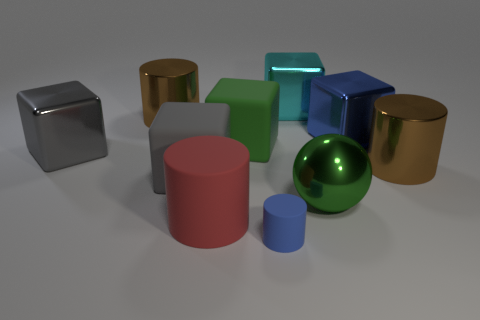What material is the large brown cylinder that is right of the small rubber cylinder to the right of the green thing left of the cyan object made of?
Your answer should be compact. Metal. Are there any other things that have the same size as the green shiny thing?
Offer a terse response. Yes. What number of matte things are big blocks or small blue cylinders?
Offer a very short reply. 3. Are there any green rubber cubes?
Give a very brief answer. Yes. There is a big shiny cylinder behind the large brown cylinder to the right of the large cyan object; what color is it?
Provide a succinct answer. Brown. How many other objects are the same color as the metal sphere?
Offer a terse response. 1. What number of objects are either cylinders or large blue metal blocks that are in front of the cyan metal block?
Make the answer very short. 5. What color is the metal cube that is to the right of the big green metal sphere?
Your answer should be very brief. Blue. What shape is the large cyan object?
Keep it short and to the point. Cube. The gray object that is in front of the brown object that is in front of the large blue metal thing is made of what material?
Your answer should be very brief. Rubber. 